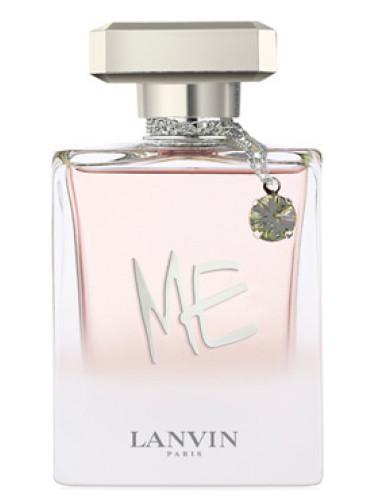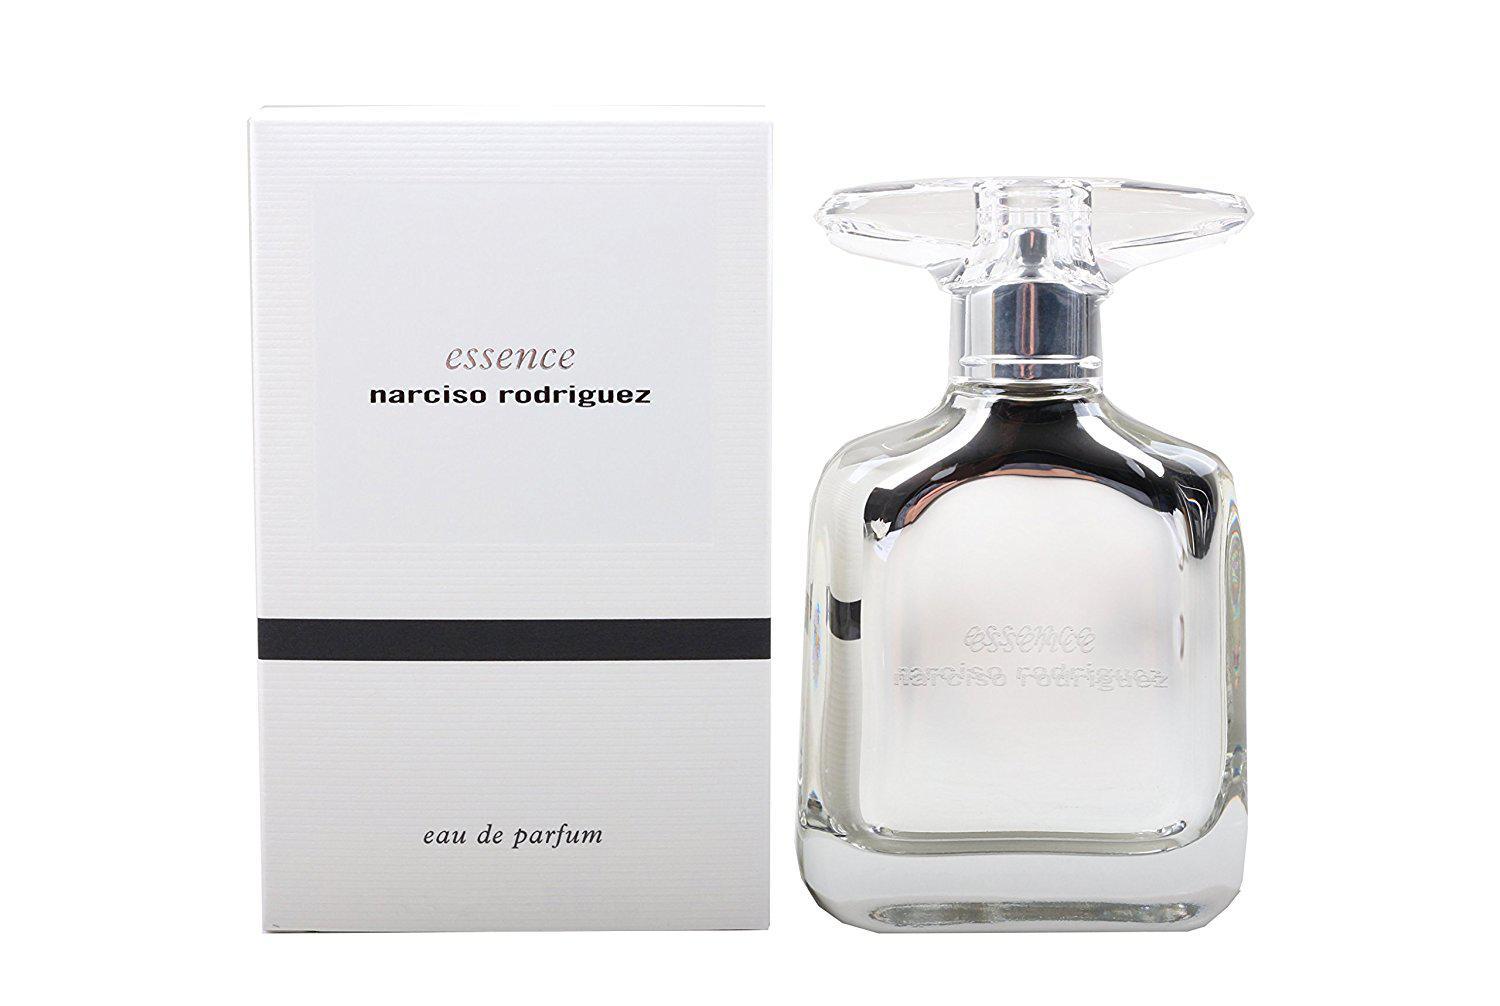The first image is the image on the left, the second image is the image on the right. For the images displayed, is the sentence "A perfume bottle is uncapped." factually correct? Answer yes or no. No. 